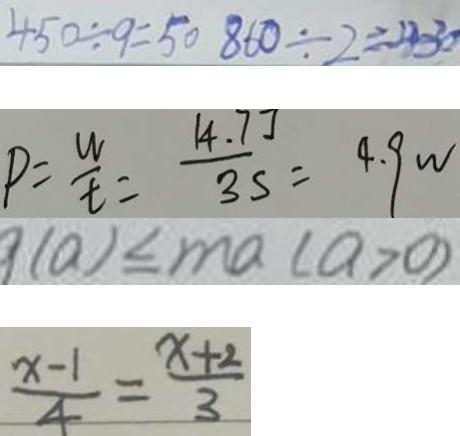Convert formula to latex. <formula><loc_0><loc_0><loc_500><loc_500>4 5 0 \div 9 = 5 0 8 6 0 \div 2 = 4 3 0 
 P = \frac { w } { t } = \frac { 1 4 . 7 J } { 3 s } = 4 . 9 w 
 9 ( a ) \leq m a ( a > 0 ) 
 \frac { x - 1 } { 4 } = \frac { x + 2 } { 3 }</formula> 